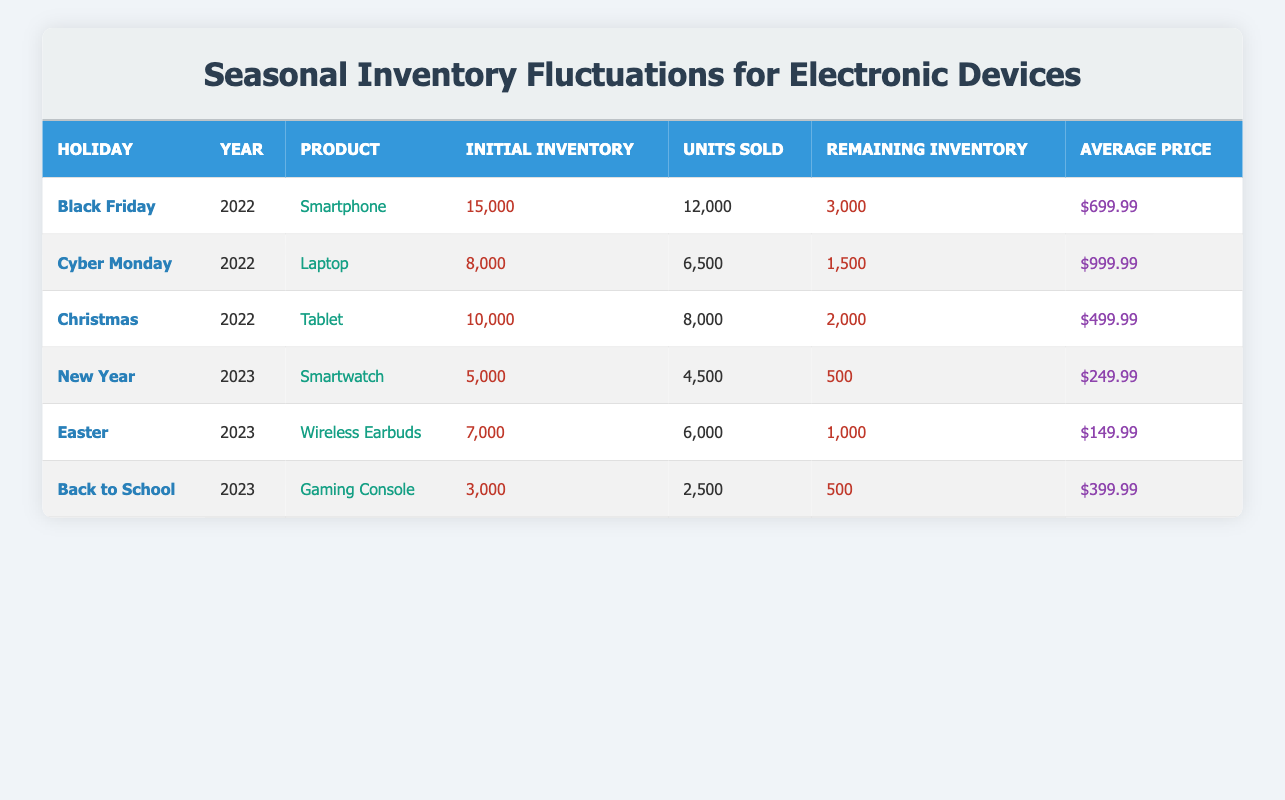What was the initial inventory of the Smartphone during Black Friday in 2022? The initial inventory for the Smartphone is directly listed in the row corresponding to Black Friday in 2022, which shows an initial inventory of 15,000.
Answer: 15,000 How many units of Tablets were sold during Christmas in 2022? The number of units sold for Tablets during Christmas is directly available in the corresponding row, which indicates that 8,000 units were sold.
Answer: 8,000 Which holiday had the least amount of remaining inventory in 2023? We compare the remaining inventory of each holiday in 2023: New Year (500), Easter (1,000), and Back to School (500). The New Year and Back to School both have the least remaining inventory, but since they are equal, we conclude that any can be considered as having the least.
Answer: New Year or Back to School Calculate the total units sold for all products during the 2022 holidays. The total units sold during 2022 are the sum from each holiday: 12,000 (Black Friday) + 6,500 (Cyber Monday) + 8,000 (Christmas) = 26,500.
Answer: 26,500 Did more units of Gaming Consoles sell than Wireless Earbuds in 2023? We look up the units sold: Gaming Consoles sold 2,500 while Wireless Earbuds sold 6,000. Since 2,500 is less than 6,000, the statement is false.
Answer: No What is the average price of products sold during the Black Friday and Cyber Monday sales? We find the average price for each of those holidays: Black Friday has an average price of $699.99 and Cyber Monday has $999.99. The total is $699.99 + $999.99 = $1,699.98. Dividing by 2 gives an average price of $849.99.
Answer: $849.99 What percentage of the initial inventory of Wireless Earbuds was sold during Easter in 2023? The initial inventory of Wireless Earbuds was 7,000, and 6,000 units were sold. To find the percentage sold, we calculate (6,000 / 7,000) * 100 = approximately 85.71%.
Answer: 85.71% Which product had the highest average price during the given holidays? From the average prices listed: Smartphone ($699.99), Laptop ($999.99), Tablet ($499.99), Smartwatch ($249.99), Wireless Earbuds ($149.99), and Gaming Console ($399.99), the Laptop has the highest price at $999.99.
Answer: Laptop How many total units were left unsold across all listed holidays? We add the remaining inventories: 3,000 (Black Friday) + 1,500 (Cyber Monday) + 2,000 (Christmas) + 500 (New Year) + 1,000 (Easter) + 500 (Back to School) = 9,500 total unsold units.
Answer: 9,500 